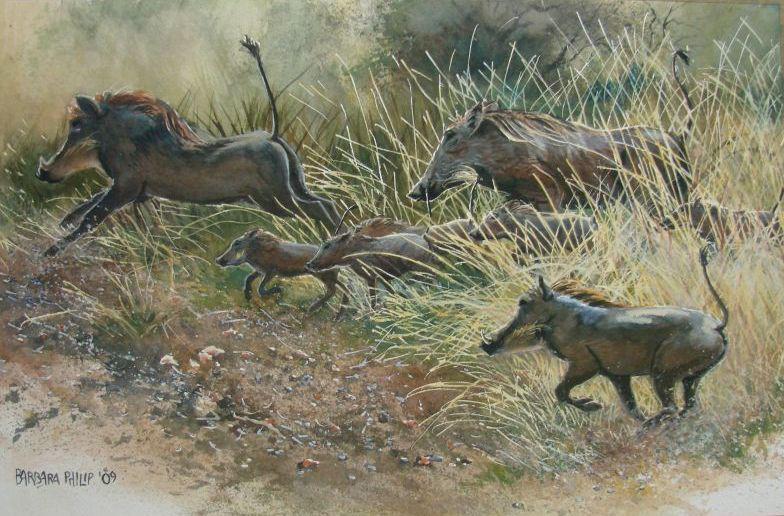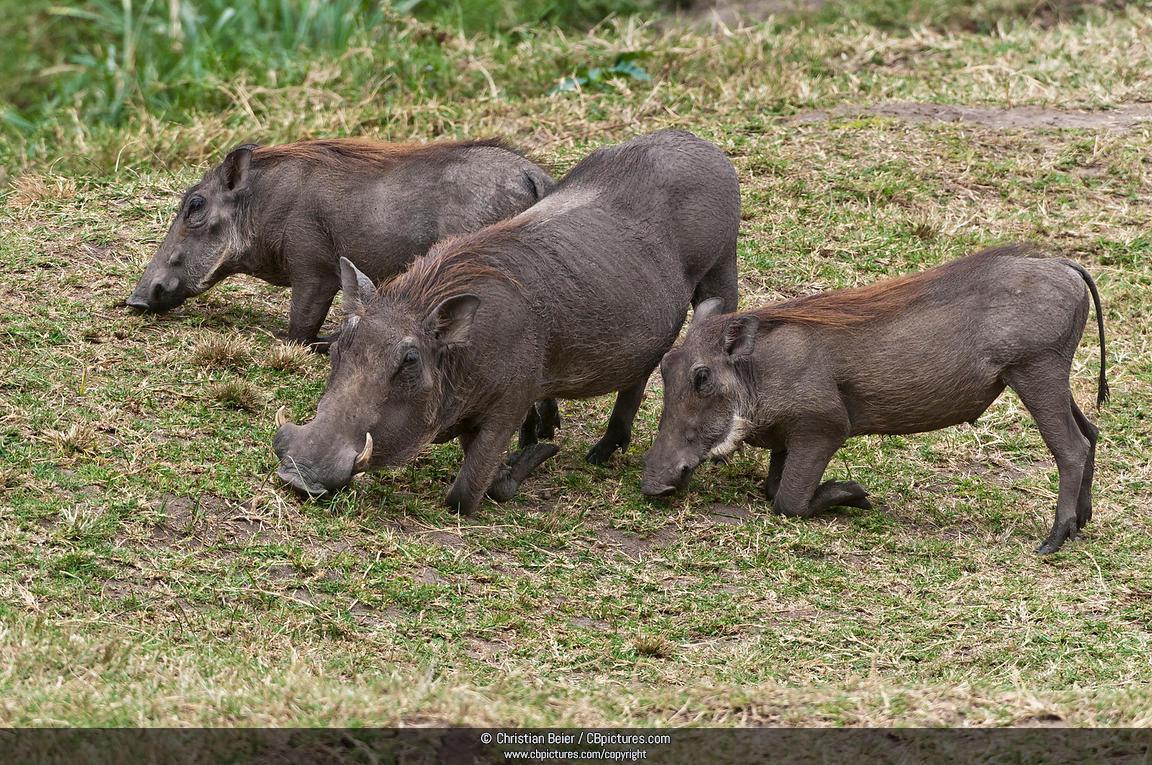The first image is the image on the left, the second image is the image on the right. Evaluate the accuracy of this statement regarding the images: "An image shows warthog on the left and spotted cat on the right.". Is it true? Answer yes or no. No. The first image is the image on the left, the second image is the image on the right. For the images displayed, is the sentence "There is a feline in one of the images." factually correct? Answer yes or no. No. 